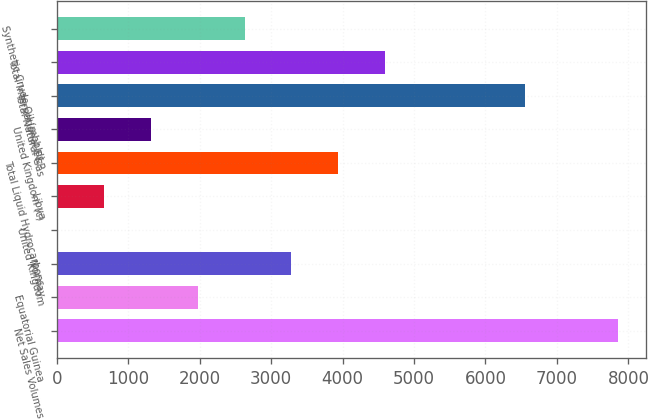Convert chart to OTSL. <chart><loc_0><loc_0><loc_500><loc_500><bar_chart><fcel>Net Sales Volumes<fcel>Equatorial Guinea<fcel>Norway<fcel>United Kingdom<fcel>Libya<fcel>Total Liquid Hydrocarbons<fcel>United Kingdom (c)<fcel>Total Natural Gas<fcel>Total International E&P<fcel>Synthetic Crude Oil (mbbld)<nl><fcel>7854.6<fcel>1974.9<fcel>3281.5<fcel>15<fcel>668.3<fcel>3934.8<fcel>1321.6<fcel>6548<fcel>4588.1<fcel>2628.2<nl></chart> 